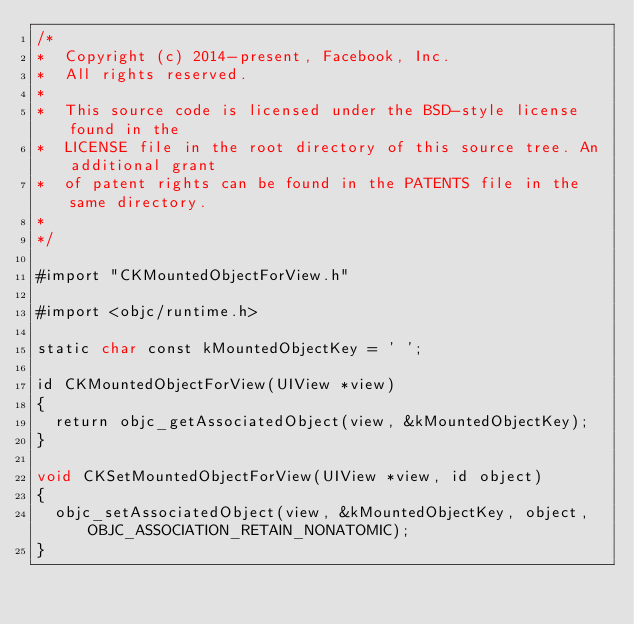<code> <loc_0><loc_0><loc_500><loc_500><_ObjectiveC_>/*
*  Copyright (c) 2014-present, Facebook, Inc.
*  All rights reserved.
*
*  This source code is licensed under the BSD-style license found in the
*  LICENSE file in the root directory of this source tree. An additional grant
*  of patent rights can be found in the PATENTS file in the same directory.
*
*/

#import "CKMountedObjectForView.h"

#import <objc/runtime.h>

static char const kMountedObjectKey = ' ';

id CKMountedObjectForView(UIView *view)
{
  return objc_getAssociatedObject(view, &kMountedObjectKey);
}

void CKSetMountedObjectForView(UIView *view, id object)
{
  objc_setAssociatedObject(view, &kMountedObjectKey, object, OBJC_ASSOCIATION_RETAIN_NONATOMIC);
}
</code> 